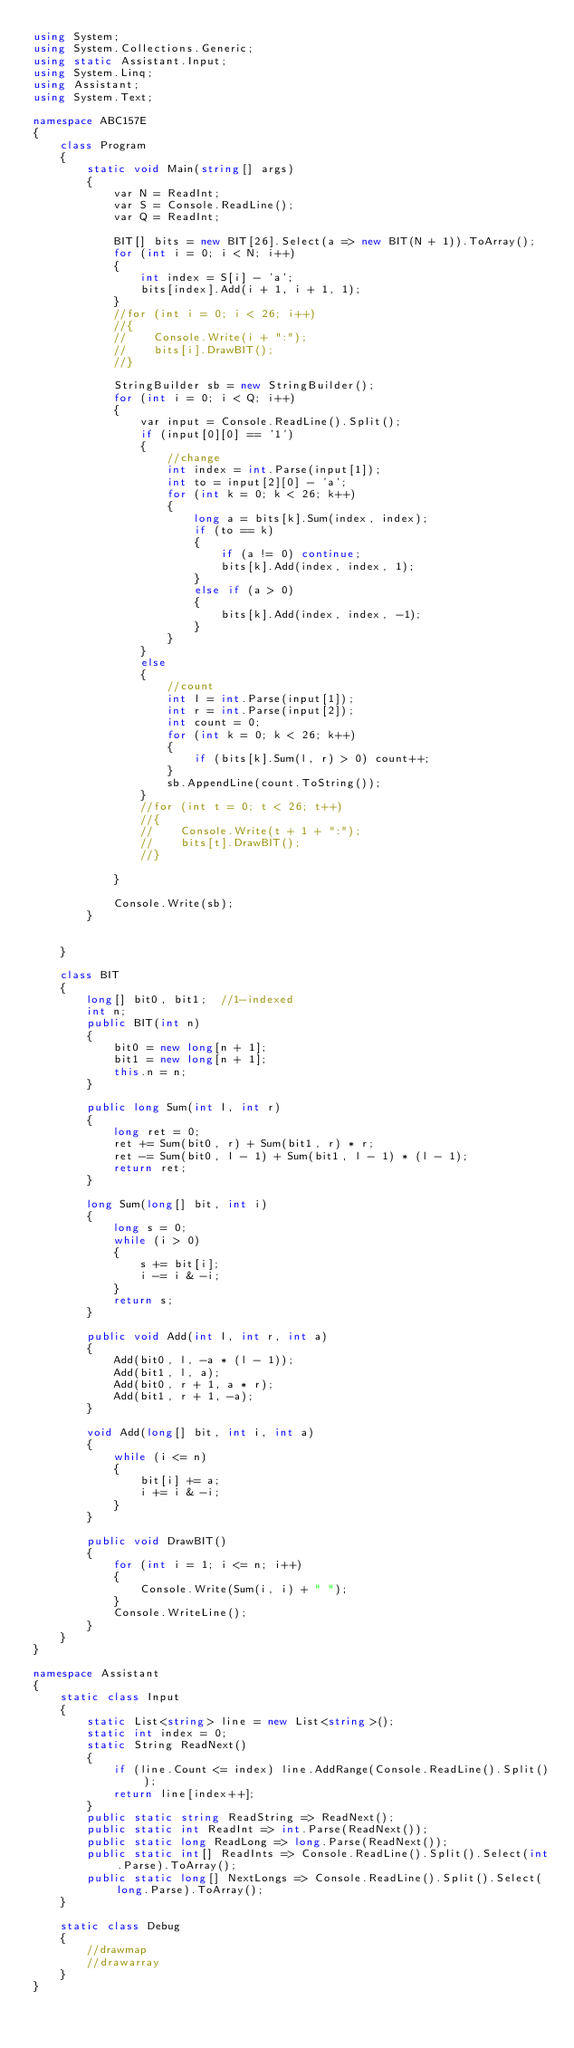<code> <loc_0><loc_0><loc_500><loc_500><_C#_>using System;
using System.Collections.Generic;
using static Assistant.Input;
using System.Linq;
using Assistant;
using System.Text;

namespace ABC157E
{
    class Program
    {
        static void Main(string[] args)
        {
            var N = ReadInt;
            var S = Console.ReadLine();
            var Q = ReadInt;

            BIT[] bits = new BIT[26].Select(a => new BIT(N + 1)).ToArray();
            for (int i = 0; i < N; i++)
            {
                int index = S[i] - 'a';
                bits[index].Add(i + 1, i + 1, 1);
            }
            //for (int i = 0; i < 26; i++)
            //{
            //    Console.Write(i + ":");
            //    bits[i].DrawBIT();
            //}

            StringBuilder sb = new StringBuilder();
            for (int i = 0; i < Q; i++)
            {
                var input = Console.ReadLine().Split();
                if (input[0][0] == '1')
                {
                    //change
                    int index = int.Parse(input[1]);
                    int to = input[2][0] - 'a';
                    for (int k = 0; k < 26; k++)
                    {
                        long a = bits[k].Sum(index, index);
                        if (to == k)
                        {
                            if (a != 0) continue;
                            bits[k].Add(index, index, 1);
                        }
                        else if (a > 0)
                        {
                            bits[k].Add(index, index, -1);
                        }
                    }
                }
                else
                {
                    //count
                    int l = int.Parse(input[1]);
                    int r = int.Parse(input[2]);
                    int count = 0;
                    for (int k = 0; k < 26; k++)
                    {
                        if (bits[k].Sum(l, r) > 0) count++;
                    }
                    sb.AppendLine(count.ToString());
                }
                //for (int t = 0; t < 26; t++)
                //{
                //    Console.Write(t + 1 + ":");
                //    bits[t].DrawBIT();
                //}

            }

            Console.Write(sb);
        }


    }

    class BIT
    {
        long[] bit0, bit1;  //1-indexed
        int n;
        public BIT(int n)
        {
            bit0 = new long[n + 1];
            bit1 = new long[n + 1];
            this.n = n;
        }

        public long Sum(int l, int r)
        {
            long ret = 0;
            ret += Sum(bit0, r) + Sum(bit1, r) * r;
            ret -= Sum(bit0, l - 1) + Sum(bit1, l - 1) * (l - 1);
            return ret;
        }

        long Sum(long[] bit, int i)
        {
            long s = 0;
            while (i > 0)
            {
                s += bit[i];
                i -= i & -i;
            }
            return s;
        }

        public void Add(int l, int r, int a)
        {
            Add(bit0, l, -a * (l - 1));
            Add(bit1, l, a);
            Add(bit0, r + 1, a * r);
            Add(bit1, r + 1, -a);
        }

        void Add(long[] bit, int i, int a)
        {
            while (i <= n)
            {
                bit[i] += a;
                i += i & -i;
            }
        }

        public void DrawBIT()
        {
            for (int i = 1; i <= n; i++)
            {
                Console.Write(Sum(i, i) + " ");
            }
            Console.WriteLine();
        }
    }
}

namespace Assistant
{
    static class Input
    {
        static List<string> line = new List<string>();
        static int index = 0;
        static String ReadNext()
        {
            if (line.Count <= index) line.AddRange(Console.ReadLine().Split());
            return line[index++];
        }
        public static string ReadString => ReadNext();
        public static int ReadInt => int.Parse(ReadNext());
        public static long ReadLong => long.Parse(ReadNext());
        public static int[] ReadInts => Console.ReadLine().Split().Select(int.Parse).ToArray();
        public static long[] NextLongs => Console.ReadLine().Split().Select(long.Parse).ToArray();
    }

    static class Debug
    {
        //drawmap
        //drawarray
    }
}
</code> 